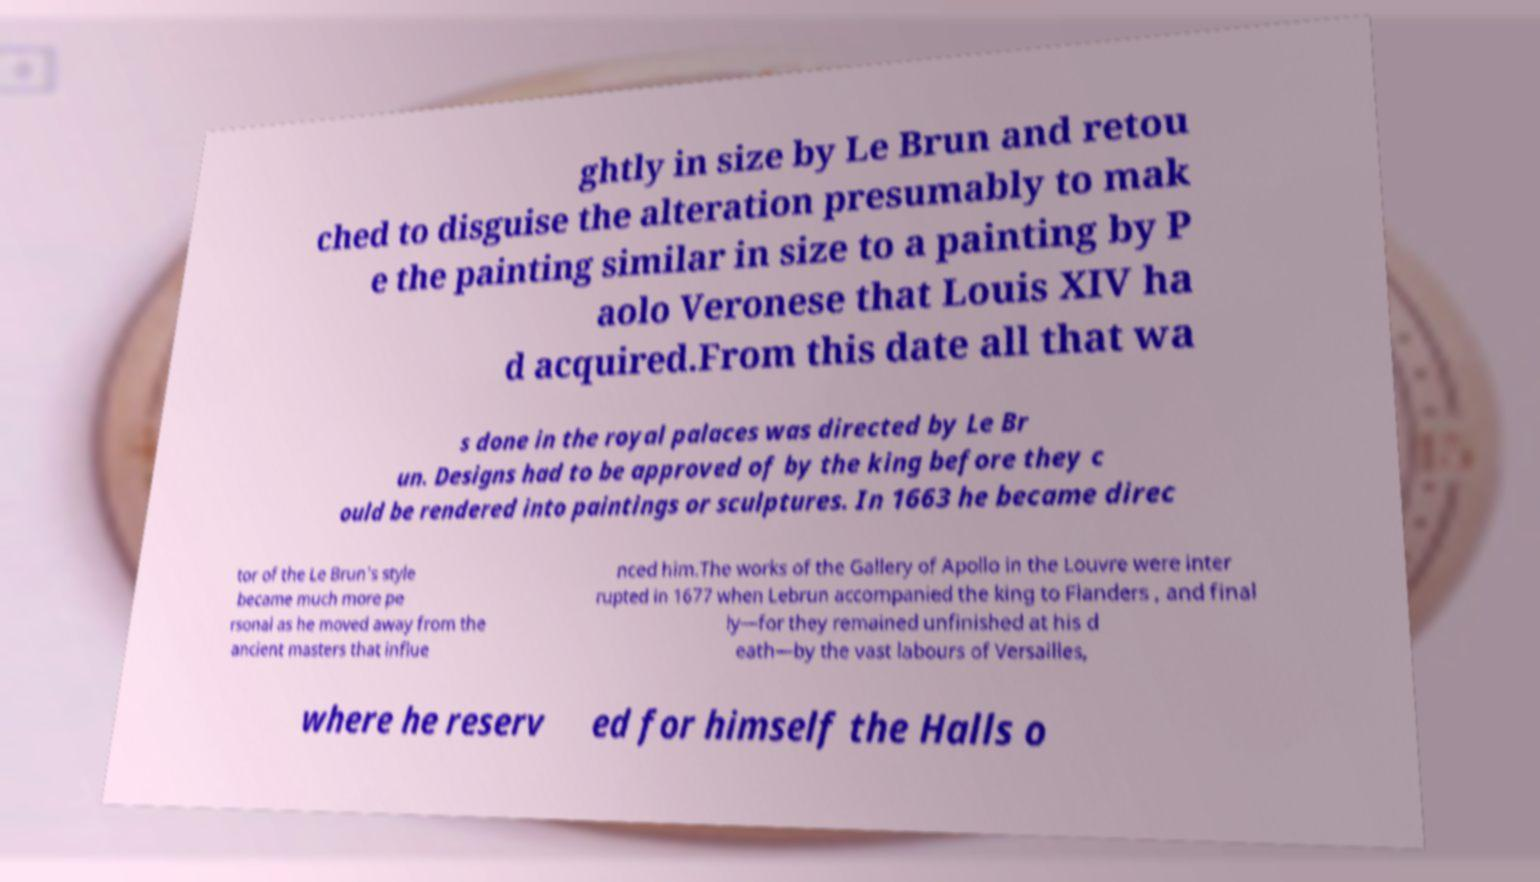What messages or text are displayed in this image? I need them in a readable, typed format. ghtly in size by Le Brun and retou ched to disguise the alteration presumably to mak e the painting similar in size to a painting by P aolo Veronese that Louis XIV ha d acquired.From this date all that wa s done in the royal palaces was directed by Le Br un. Designs had to be approved of by the king before they c ould be rendered into paintings or sculptures. In 1663 he became direc tor of the Le Brun's style became much more pe rsonal as he moved away from the ancient masters that influe nced him.The works of the Gallery of Apollo in the Louvre were inter rupted in 1677 when Lebrun accompanied the king to Flanders , and final ly—for they remained unfinished at his d eath—by the vast labours of Versailles, where he reserv ed for himself the Halls o 